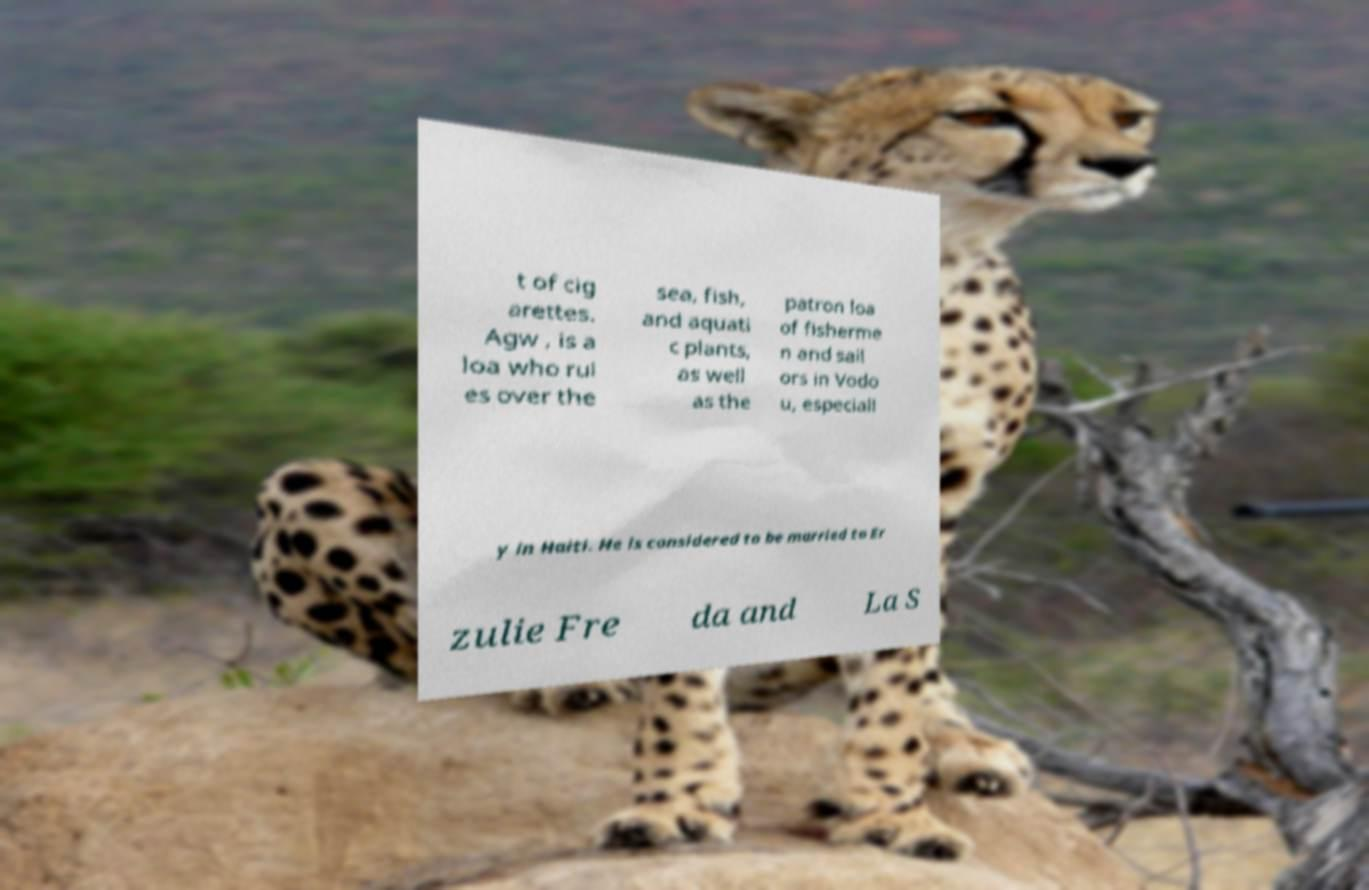Could you assist in decoding the text presented in this image and type it out clearly? t of cig arettes. Agw , is a loa who rul es over the sea, fish, and aquati c plants, as well as the patron loa of fisherme n and sail ors in Vodo u, especiall y in Haiti. He is considered to be married to Er zulie Fre da and La S 